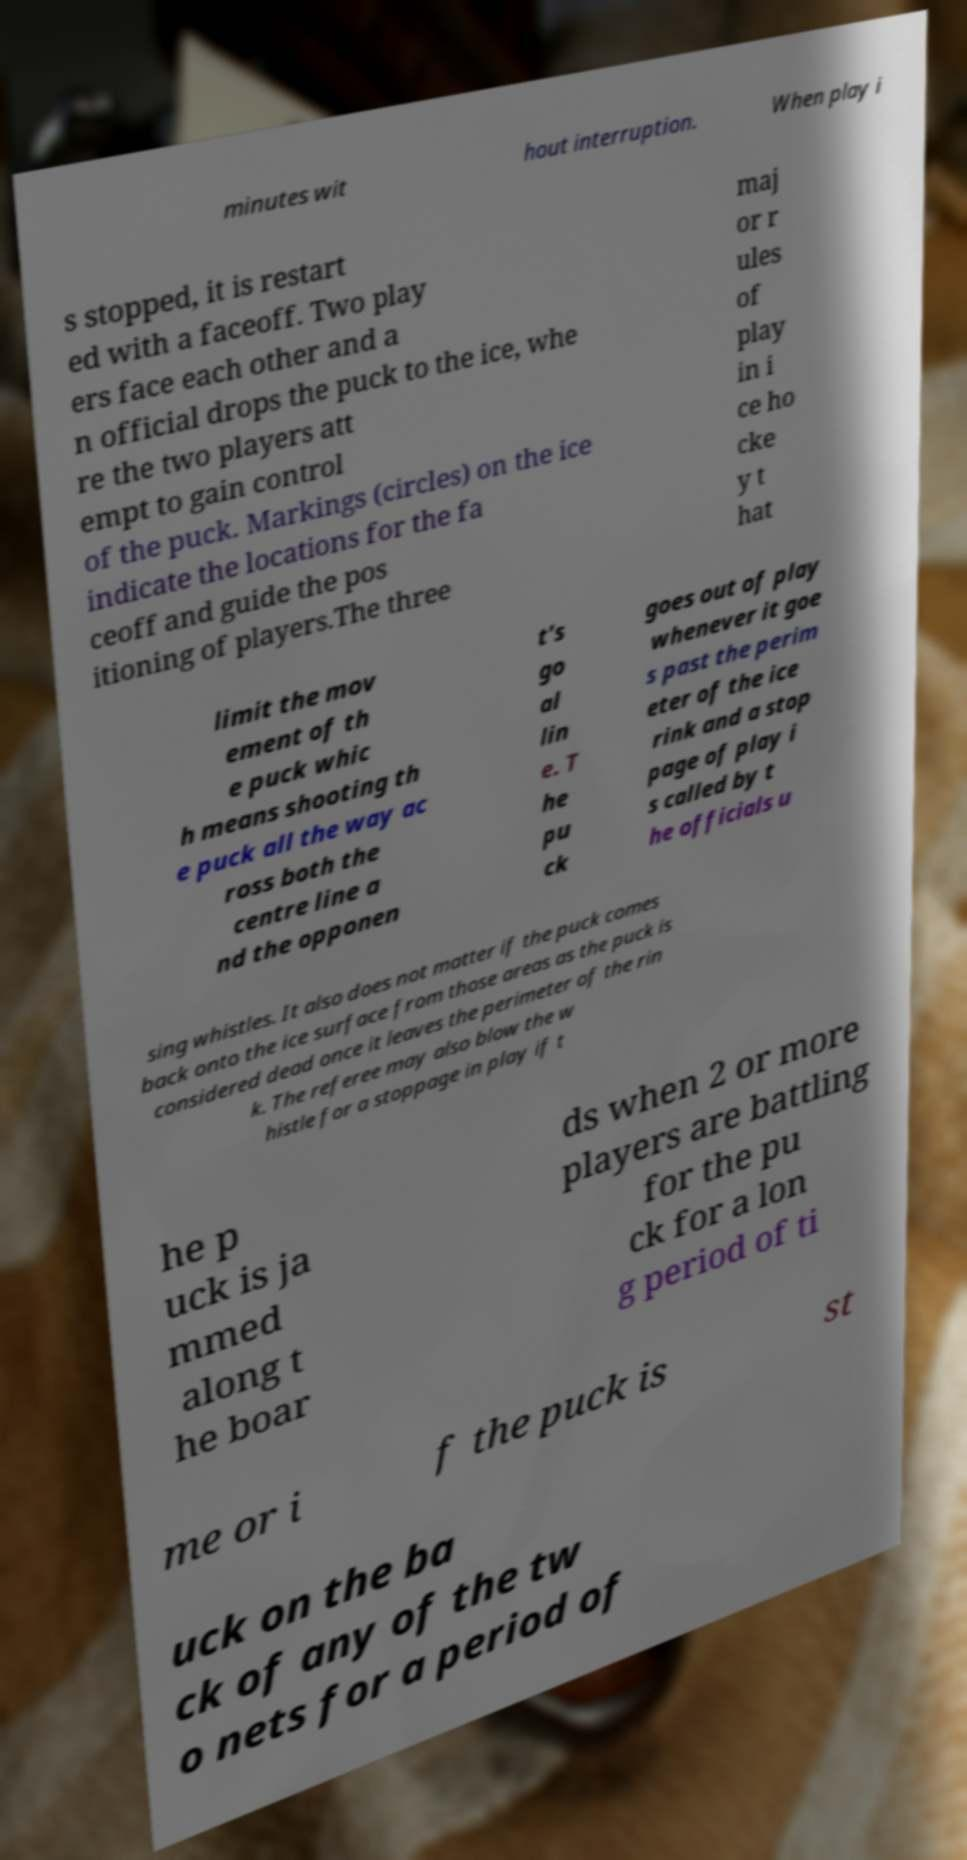Can you read and provide the text displayed in the image?This photo seems to have some interesting text. Can you extract and type it out for me? minutes wit hout interruption. When play i s stopped, it is restart ed with a faceoff. Two play ers face each other and a n official drops the puck to the ice, whe re the two players att empt to gain control of the puck. Markings (circles) on the ice indicate the locations for the fa ceoff and guide the pos itioning of players.The three maj or r ules of play in i ce ho cke y t hat limit the mov ement of th e puck whic h means shooting th e puck all the way ac ross both the centre line a nd the opponen t's go al lin e. T he pu ck goes out of play whenever it goe s past the perim eter of the ice rink and a stop page of play i s called by t he officials u sing whistles. It also does not matter if the puck comes back onto the ice surface from those areas as the puck is considered dead once it leaves the perimeter of the rin k. The referee may also blow the w histle for a stoppage in play if t he p uck is ja mmed along t he boar ds when 2 or more players are battling for the pu ck for a lon g period of ti me or i f the puck is st uck on the ba ck of any of the tw o nets for a period of 